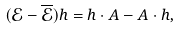Convert formula to latex. <formula><loc_0><loc_0><loc_500><loc_500>( \mathcal { E } - \overline { \mathcal { E } } ) h = h \cdot A - A \cdot h ,</formula> 